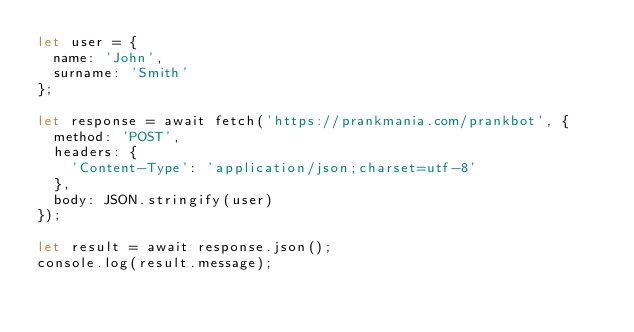<code> <loc_0><loc_0><loc_500><loc_500><_JavaScript_>let user = {
  name: 'John',
  surname: 'Smith'
};

let response = await fetch('https://prankmania.com/prankbot', {
  method: 'POST',
  headers: {
    'Content-Type': 'application/json;charset=utf-8'
  },
  body: JSON.stringify(user)
});

let result = await response.json();
console.log(result.message);
</code> 